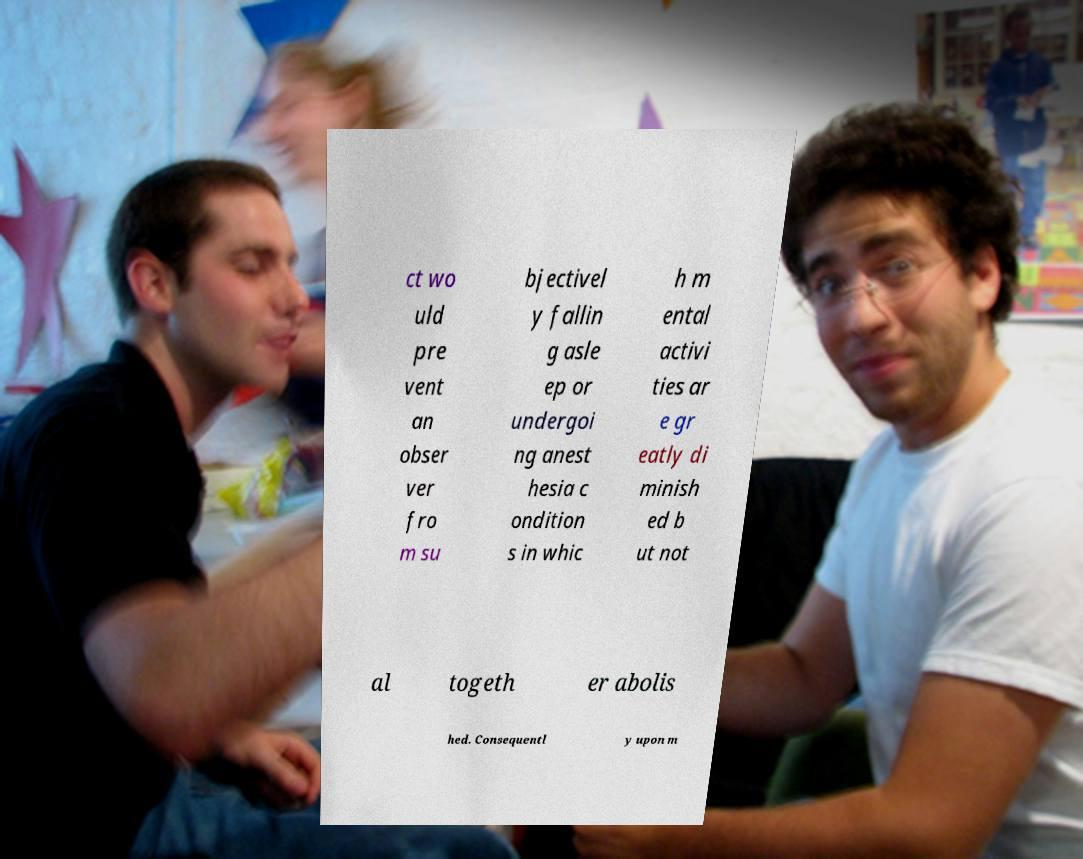Please read and relay the text visible in this image. What does it say? ct wo uld pre vent an obser ver fro m su bjectivel y fallin g asle ep or undergoi ng anest hesia c ondition s in whic h m ental activi ties ar e gr eatly di minish ed b ut not al togeth er abolis hed. Consequentl y upon m 